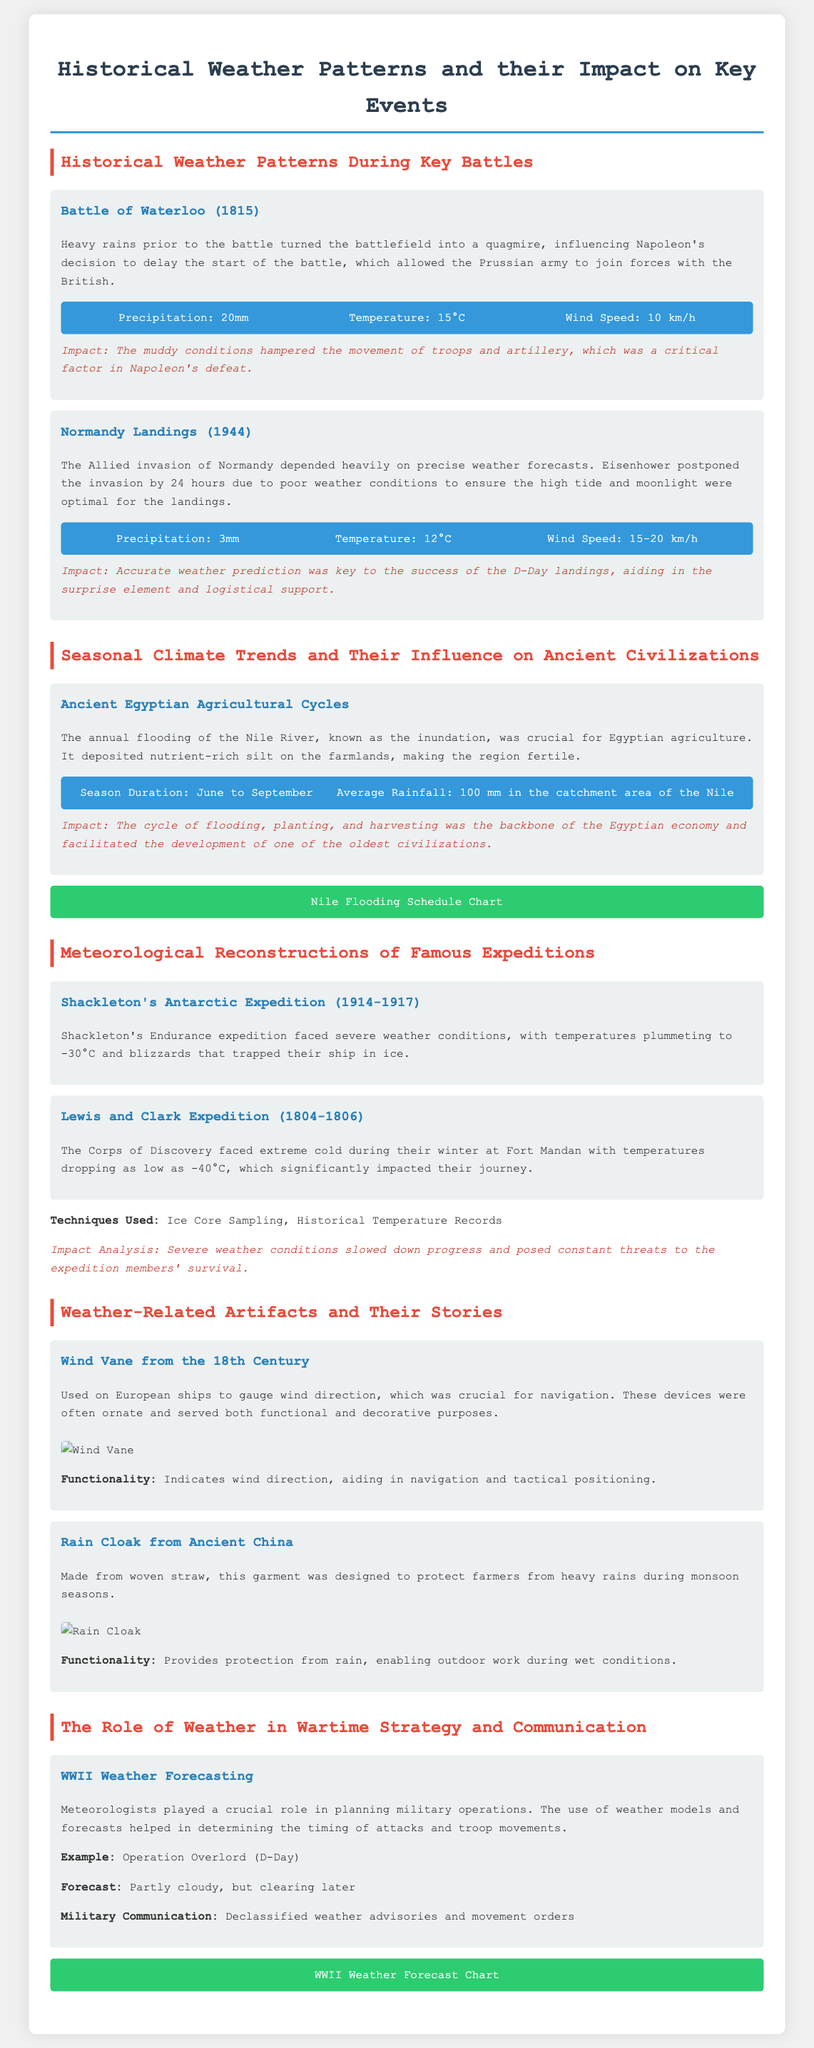What was the precipitation during the Battle of Waterloo? The document states that the precipitation during the Battle of Waterloo was 20mm.
Answer: 20mm What temperature was recorded during the Normandy Landings? According to the document, the temperature during the Normandy Landings was 12°C.
Answer: 12°C What was the impact of the muddy conditions at the Battle of Waterloo? The muddy conditions hampered the movement of troops and artillery, which was a critical factor in Napoleon's defeat.
Answer: Hampered movement of troops and artillery What was the function of the wind vane from the 18th century? The document explains that the functionality of the wind vane was to indicate wind direction, aiding in navigation and tactical positioning.
Answer: Indicates wind direction How did the annual flooding of the Nile River affect ancient Egyptian agriculture? The document mentions that the annual flooding deposited nutrient-rich silt, making the region fertile, which was crucial for Egyptian agriculture.
Answer: Made region fertile What severe weather issue was faced during Shackleton's Antarctic Expedition? The document notes that Shackleton's expedition faced severe weather conditions, with temperatures plummeting to -30°C and blizzards.
Answer: Temperatures plummeting to -30°C What critical decision was made by Eisenhower regarding the Normandy landings? Eisenhower postponed the invasion by 24 hours due to poor weather conditions to ensure optimal landing conditions.
Answer: Postponed invasion by 24 hours What was the average rainfall in the catchment area of the Nile? The document states the average rainfall in the catchment area of the Nile was 100 mm.
Answer: 100 mm What information was used for planning military operations during WWII? Meteorologists used weather models and forecasts to determine the timing of attacks and troop movements.
Answer: Weather models and forecasts 